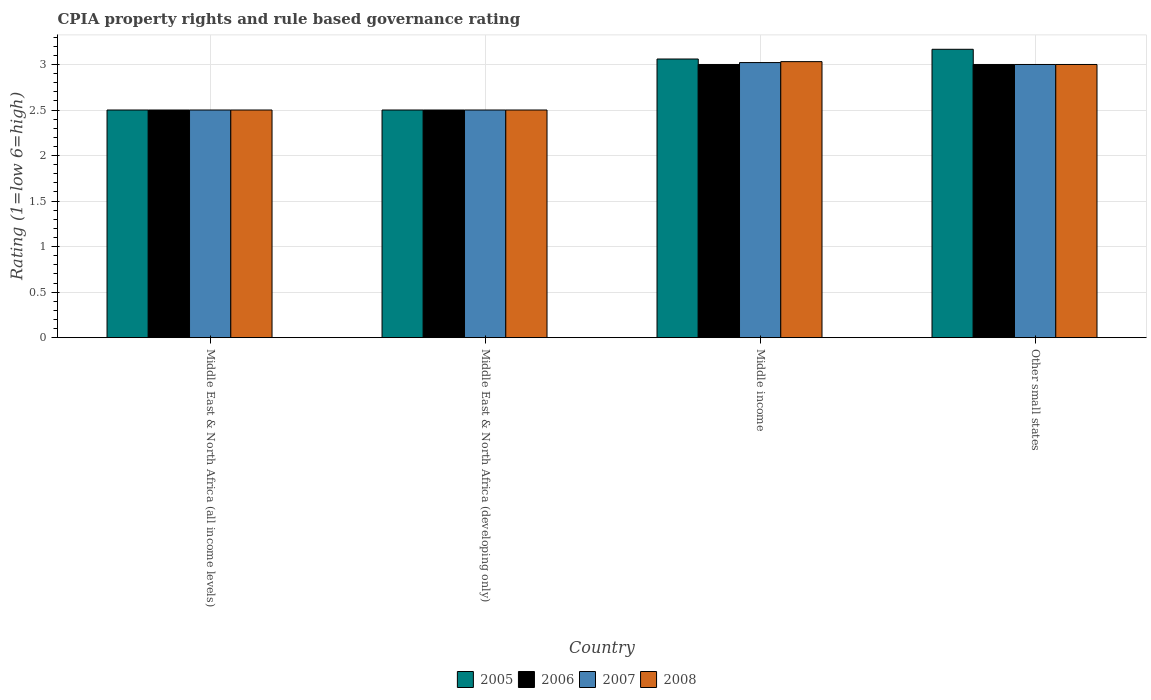How many different coloured bars are there?
Your answer should be very brief. 4. How many groups of bars are there?
Give a very brief answer. 4. Are the number of bars per tick equal to the number of legend labels?
Provide a short and direct response. Yes. Are the number of bars on each tick of the X-axis equal?
Make the answer very short. Yes. How many bars are there on the 2nd tick from the left?
Ensure brevity in your answer.  4. What is the label of the 4th group of bars from the left?
Your answer should be very brief. Other small states. What is the CPIA rating in 2008 in Middle East & North Africa (developing only)?
Ensure brevity in your answer.  2.5. Across all countries, what is the maximum CPIA rating in 2005?
Make the answer very short. 3.17. In which country was the CPIA rating in 2006 minimum?
Offer a terse response. Middle East & North Africa (all income levels). What is the total CPIA rating in 2005 in the graph?
Give a very brief answer. 11.23. What is the average CPIA rating in 2007 per country?
Give a very brief answer. 2.76. What is the difference between the CPIA rating of/in 2005 and CPIA rating of/in 2007 in Other small states?
Make the answer very short. 0.17. In how many countries, is the CPIA rating in 2006 greater than 3.1?
Your response must be concise. 0. What is the ratio of the CPIA rating in 2006 in Middle East & North Africa (developing only) to that in Other small states?
Your answer should be very brief. 0.83. Is the difference between the CPIA rating in 2005 in Middle income and Other small states greater than the difference between the CPIA rating in 2007 in Middle income and Other small states?
Your response must be concise. No. What is the difference between the highest and the lowest CPIA rating in 2006?
Your answer should be compact. 0.5. Are all the bars in the graph horizontal?
Provide a succinct answer. No. How many countries are there in the graph?
Offer a very short reply. 4. Are the values on the major ticks of Y-axis written in scientific E-notation?
Make the answer very short. No. Does the graph contain any zero values?
Give a very brief answer. No. How many legend labels are there?
Your answer should be compact. 4. How are the legend labels stacked?
Keep it short and to the point. Horizontal. What is the title of the graph?
Keep it short and to the point. CPIA property rights and rule based governance rating. Does "2012" appear as one of the legend labels in the graph?
Provide a short and direct response. No. What is the label or title of the X-axis?
Give a very brief answer. Country. What is the Rating (1=low 6=high) in 2005 in Middle East & North Africa (developing only)?
Make the answer very short. 2.5. What is the Rating (1=low 6=high) of 2006 in Middle East & North Africa (developing only)?
Ensure brevity in your answer.  2.5. What is the Rating (1=low 6=high) in 2007 in Middle East & North Africa (developing only)?
Make the answer very short. 2.5. What is the Rating (1=low 6=high) of 2008 in Middle East & North Africa (developing only)?
Give a very brief answer. 2.5. What is the Rating (1=low 6=high) of 2005 in Middle income?
Your answer should be very brief. 3.06. What is the Rating (1=low 6=high) of 2006 in Middle income?
Provide a short and direct response. 3. What is the Rating (1=low 6=high) of 2007 in Middle income?
Make the answer very short. 3.02. What is the Rating (1=low 6=high) of 2008 in Middle income?
Provide a short and direct response. 3.03. What is the Rating (1=low 6=high) of 2005 in Other small states?
Provide a succinct answer. 3.17. What is the Rating (1=low 6=high) in 2007 in Other small states?
Offer a very short reply. 3. Across all countries, what is the maximum Rating (1=low 6=high) in 2005?
Provide a short and direct response. 3.17. Across all countries, what is the maximum Rating (1=low 6=high) of 2006?
Offer a very short reply. 3. Across all countries, what is the maximum Rating (1=low 6=high) in 2007?
Make the answer very short. 3.02. Across all countries, what is the maximum Rating (1=low 6=high) of 2008?
Provide a short and direct response. 3.03. Across all countries, what is the minimum Rating (1=low 6=high) of 2005?
Keep it short and to the point. 2.5. Across all countries, what is the minimum Rating (1=low 6=high) in 2006?
Provide a short and direct response. 2.5. Across all countries, what is the minimum Rating (1=low 6=high) in 2007?
Provide a short and direct response. 2.5. Across all countries, what is the minimum Rating (1=low 6=high) of 2008?
Provide a short and direct response. 2.5. What is the total Rating (1=low 6=high) of 2005 in the graph?
Ensure brevity in your answer.  11.23. What is the total Rating (1=low 6=high) of 2007 in the graph?
Offer a very short reply. 11.02. What is the total Rating (1=low 6=high) in 2008 in the graph?
Keep it short and to the point. 11.03. What is the difference between the Rating (1=low 6=high) in 2005 in Middle East & North Africa (all income levels) and that in Middle East & North Africa (developing only)?
Keep it short and to the point. 0. What is the difference between the Rating (1=low 6=high) of 2006 in Middle East & North Africa (all income levels) and that in Middle East & North Africa (developing only)?
Offer a very short reply. 0. What is the difference between the Rating (1=low 6=high) in 2007 in Middle East & North Africa (all income levels) and that in Middle East & North Africa (developing only)?
Your response must be concise. 0. What is the difference between the Rating (1=low 6=high) of 2005 in Middle East & North Africa (all income levels) and that in Middle income?
Ensure brevity in your answer.  -0.56. What is the difference between the Rating (1=low 6=high) of 2007 in Middle East & North Africa (all income levels) and that in Middle income?
Offer a very short reply. -0.52. What is the difference between the Rating (1=low 6=high) of 2008 in Middle East & North Africa (all income levels) and that in Middle income?
Ensure brevity in your answer.  -0.53. What is the difference between the Rating (1=low 6=high) of 2006 in Middle East & North Africa (all income levels) and that in Other small states?
Offer a terse response. -0.5. What is the difference between the Rating (1=low 6=high) in 2008 in Middle East & North Africa (all income levels) and that in Other small states?
Offer a very short reply. -0.5. What is the difference between the Rating (1=low 6=high) of 2005 in Middle East & North Africa (developing only) and that in Middle income?
Your response must be concise. -0.56. What is the difference between the Rating (1=low 6=high) of 2006 in Middle East & North Africa (developing only) and that in Middle income?
Offer a terse response. -0.5. What is the difference between the Rating (1=low 6=high) in 2007 in Middle East & North Africa (developing only) and that in Middle income?
Your answer should be compact. -0.52. What is the difference between the Rating (1=low 6=high) in 2008 in Middle East & North Africa (developing only) and that in Middle income?
Offer a terse response. -0.53. What is the difference between the Rating (1=low 6=high) of 2007 in Middle East & North Africa (developing only) and that in Other small states?
Your response must be concise. -0.5. What is the difference between the Rating (1=low 6=high) of 2005 in Middle income and that in Other small states?
Your response must be concise. -0.11. What is the difference between the Rating (1=low 6=high) of 2006 in Middle income and that in Other small states?
Keep it short and to the point. 0. What is the difference between the Rating (1=low 6=high) of 2007 in Middle income and that in Other small states?
Provide a succinct answer. 0.02. What is the difference between the Rating (1=low 6=high) of 2008 in Middle income and that in Other small states?
Make the answer very short. 0.03. What is the difference between the Rating (1=low 6=high) in 2005 in Middle East & North Africa (all income levels) and the Rating (1=low 6=high) in 2006 in Middle East & North Africa (developing only)?
Your answer should be very brief. 0. What is the difference between the Rating (1=low 6=high) of 2005 in Middle East & North Africa (all income levels) and the Rating (1=low 6=high) of 2007 in Middle East & North Africa (developing only)?
Make the answer very short. 0. What is the difference between the Rating (1=low 6=high) in 2007 in Middle East & North Africa (all income levels) and the Rating (1=low 6=high) in 2008 in Middle East & North Africa (developing only)?
Your answer should be very brief. 0. What is the difference between the Rating (1=low 6=high) in 2005 in Middle East & North Africa (all income levels) and the Rating (1=low 6=high) in 2007 in Middle income?
Your answer should be compact. -0.52. What is the difference between the Rating (1=low 6=high) in 2005 in Middle East & North Africa (all income levels) and the Rating (1=low 6=high) in 2008 in Middle income?
Offer a very short reply. -0.53. What is the difference between the Rating (1=low 6=high) of 2006 in Middle East & North Africa (all income levels) and the Rating (1=low 6=high) of 2007 in Middle income?
Your answer should be very brief. -0.52. What is the difference between the Rating (1=low 6=high) in 2006 in Middle East & North Africa (all income levels) and the Rating (1=low 6=high) in 2008 in Middle income?
Your answer should be very brief. -0.53. What is the difference between the Rating (1=low 6=high) in 2007 in Middle East & North Africa (all income levels) and the Rating (1=low 6=high) in 2008 in Middle income?
Provide a short and direct response. -0.53. What is the difference between the Rating (1=low 6=high) of 2005 in Middle East & North Africa (all income levels) and the Rating (1=low 6=high) of 2006 in Other small states?
Provide a succinct answer. -0.5. What is the difference between the Rating (1=low 6=high) in 2006 in Middle East & North Africa (all income levels) and the Rating (1=low 6=high) in 2008 in Other small states?
Give a very brief answer. -0.5. What is the difference between the Rating (1=low 6=high) of 2005 in Middle East & North Africa (developing only) and the Rating (1=low 6=high) of 2007 in Middle income?
Give a very brief answer. -0.52. What is the difference between the Rating (1=low 6=high) in 2005 in Middle East & North Africa (developing only) and the Rating (1=low 6=high) in 2008 in Middle income?
Offer a terse response. -0.53. What is the difference between the Rating (1=low 6=high) of 2006 in Middle East & North Africa (developing only) and the Rating (1=low 6=high) of 2007 in Middle income?
Keep it short and to the point. -0.52. What is the difference between the Rating (1=low 6=high) of 2006 in Middle East & North Africa (developing only) and the Rating (1=low 6=high) of 2008 in Middle income?
Your response must be concise. -0.53. What is the difference between the Rating (1=low 6=high) in 2007 in Middle East & North Africa (developing only) and the Rating (1=low 6=high) in 2008 in Middle income?
Ensure brevity in your answer.  -0.53. What is the difference between the Rating (1=low 6=high) of 2005 in Middle East & North Africa (developing only) and the Rating (1=low 6=high) of 2006 in Other small states?
Offer a very short reply. -0.5. What is the difference between the Rating (1=low 6=high) in 2006 in Middle East & North Africa (developing only) and the Rating (1=low 6=high) in 2007 in Other small states?
Give a very brief answer. -0.5. What is the difference between the Rating (1=low 6=high) of 2005 in Middle income and the Rating (1=low 6=high) of 2006 in Other small states?
Offer a terse response. 0.06. What is the difference between the Rating (1=low 6=high) of 2005 in Middle income and the Rating (1=low 6=high) of 2008 in Other small states?
Provide a short and direct response. 0.06. What is the difference between the Rating (1=low 6=high) in 2007 in Middle income and the Rating (1=low 6=high) in 2008 in Other small states?
Your response must be concise. 0.02. What is the average Rating (1=low 6=high) of 2005 per country?
Your response must be concise. 2.81. What is the average Rating (1=low 6=high) in 2006 per country?
Offer a very short reply. 2.75. What is the average Rating (1=low 6=high) of 2007 per country?
Ensure brevity in your answer.  2.76. What is the average Rating (1=low 6=high) of 2008 per country?
Provide a short and direct response. 2.76. What is the difference between the Rating (1=low 6=high) of 2005 and Rating (1=low 6=high) of 2007 in Middle East & North Africa (all income levels)?
Ensure brevity in your answer.  0. What is the difference between the Rating (1=low 6=high) of 2005 and Rating (1=low 6=high) of 2008 in Middle East & North Africa (all income levels)?
Your response must be concise. 0. What is the difference between the Rating (1=low 6=high) of 2006 and Rating (1=low 6=high) of 2007 in Middle East & North Africa (all income levels)?
Your response must be concise. 0. What is the difference between the Rating (1=low 6=high) in 2005 and Rating (1=low 6=high) in 2006 in Middle East & North Africa (developing only)?
Your response must be concise. 0. What is the difference between the Rating (1=low 6=high) in 2005 and Rating (1=low 6=high) in 2007 in Middle income?
Make the answer very short. 0.04. What is the difference between the Rating (1=low 6=high) of 2005 and Rating (1=low 6=high) of 2008 in Middle income?
Make the answer very short. 0.03. What is the difference between the Rating (1=low 6=high) in 2006 and Rating (1=low 6=high) in 2007 in Middle income?
Give a very brief answer. -0.02. What is the difference between the Rating (1=low 6=high) of 2006 and Rating (1=low 6=high) of 2008 in Middle income?
Keep it short and to the point. -0.03. What is the difference between the Rating (1=low 6=high) of 2007 and Rating (1=low 6=high) of 2008 in Middle income?
Provide a short and direct response. -0.01. What is the difference between the Rating (1=low 6=high) of 2006 and Rating (1=low 6=high) of 2007 in Other small states?
Give a very brief answer. 0. What is the difference between the Rating (1=low 6=high) of 2006 and Rating (1=low 6=high) of 2008 in Other small states?
Provide a short and direct response. 0. What is the difference between the Rating (1=low 6=high) in 2007 and Rating (1=low 6=high) in 2008 in Other small states?
Give a very brief answer. 0. What is the ratio of the Rating (1=low 6=high) in 2005 in Middle East & North Africa (all income levels) to that in Middle East & North Africa (developing only)?
Your answer should be compact. 1. What is the ratio of the Rating (1=low 6=high) in 2007 in Middle East & North Africa (all income levels) to that in Middle East & North Africa (developing only)?
Ensure brevity in your answer.  1. What is the ratio of the Rating (1=low 6=high) in 2008 in Middle East & North Africa (all income levels) to that in Middle East & North Africa (developing only)?
Your response must be concise. 1. What is the ratio of the Rating (1=low 6=high) in 2005 in Middle East & North Africa (all income levels) to that in Middle income?
Your response must be concise. 0.82. What is the ratio of the Rating (1=low 6=high) in 2007 in Middle East & North Africa (all income levels) to that in Middle income?
Your response must be concise. 0.83. What is the ratio of the Rating (1=low 6=high) in 2008 in Middle East & North Africa (all income levels) to that in Middle income?
Keep it short and to the point. 0.82. What is the ratio of the Rating (1=low 6=high) of 2005 in Middle East & North Africa (all income levels) to that in Other small states?
Give a very brief answer. 0.79. What is the ratio of the Rating (1=low 6=high) in 2007 in Middle East & North Africa (all income levels) to that in Other small states?
Your response must be concise. 0.83. What is the ratio of the Rating (1=low 6=high) in 2005 in Middle East & North Africa (developing only) to that in Middle income?
Provide a succinct answer. 0.82. What is the ratio of the Rating (1=low 6=high) in 2006 in Middle East & North Africa (developing only) to that in Middle income?
Give a very brief answer. 0.83. What is the ratio of the Rating (1=low 6=high) in 2007 in Middle East & North Africa (developing only) to that in Middle income?
Provide a short and direct response. 0.83. What is the ratio of the Rating (1=low 6=high) in 2008 in Middle East & North Africa (developing only) to that in Middle income?
Your response must be concise. 0.82. What is the ratio of the Rating (1=low 6=high) of 2005 in Middle East & North Africa (developing only) to that in Other small states?
Your answer should be very brief. 0.79. What is the ratio of the Rating (1=low 6=high) of 2006 in Middle East & North Africa (developing only) to that in Other small states?
Your answer should be compact. 0.83. What is the ratio of the Rating (1=low 6=high) in 2008 in Middle East & North Africa (developing only) to that in Other small states?
Make the answer very short. 0.83. What is the ratio of the Rating (1=low 6=high) of 2005 in Middle income to that in Other small states?
Provide a short and direct response. 0.97. What is the ratio of the Rating (1=low 6=high) in 2008 in Middle income to that in Other small states?
Offer a very short reply. 1.01. What is the difference between the highest and the second highest Rating (1=low 6=high) in 2005?
Provide a succinct answer. 0.11. What is the difference between the highest and the second highest Rating (1=low 6=high) of 2007?
Offer a terse response. 0.02. What is the difference between the highest and the second highest Rating (1=low 6=high) in 2008?
Your answer should be very brief. 0.03. What is the difference between the highest and the lowest Rating (1=low 6=high) in 2005?
Provide a short and direct response. 0.67. What is the difference between the highest and the lowest Rating (1=low 6=high) in 2006?
Your answer should be very brief. 0.5. What is the difference between the highest and the lowest Rating (1=low 6=high) of 2007?
Provide a short and direct response. 0.52. What is the difference between the highest and the lowest Rating (1=low 6=high) of 2008?
Offer a very short reply. 0.53. 